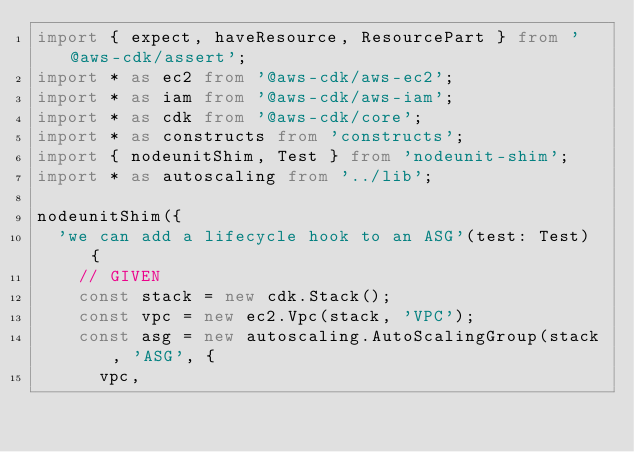Convert code to text. <code><loc_0><loc_0><loc_500><loc_500><_TypeScript_>import { expect, haveResource, ResourcePart } from '@aws-cdk/assert';
import * as ec2 from '@aws-cdk/aws-ec2';
import * as iam from '@aws-cdk/aws-iam';
import * as cdk from '@aws-cdk/core';
import * as constructs from 'constructs';
import { nodeunitShim, Test } from 'nodeunit-shim';
import * as autoscaling from '../lib';

nodeunitShim({
  'we can add a lifecycle hook to an ASG'(test: Test) {
    // GIVEN
    const stack = new cdk.Stack();
    const vpc = new ec2.Vpc(stack, 'VPC');
    const asg = new autoscaling.AutoScalingGroup(stack, 'ASG', {
      vpc,</code> 